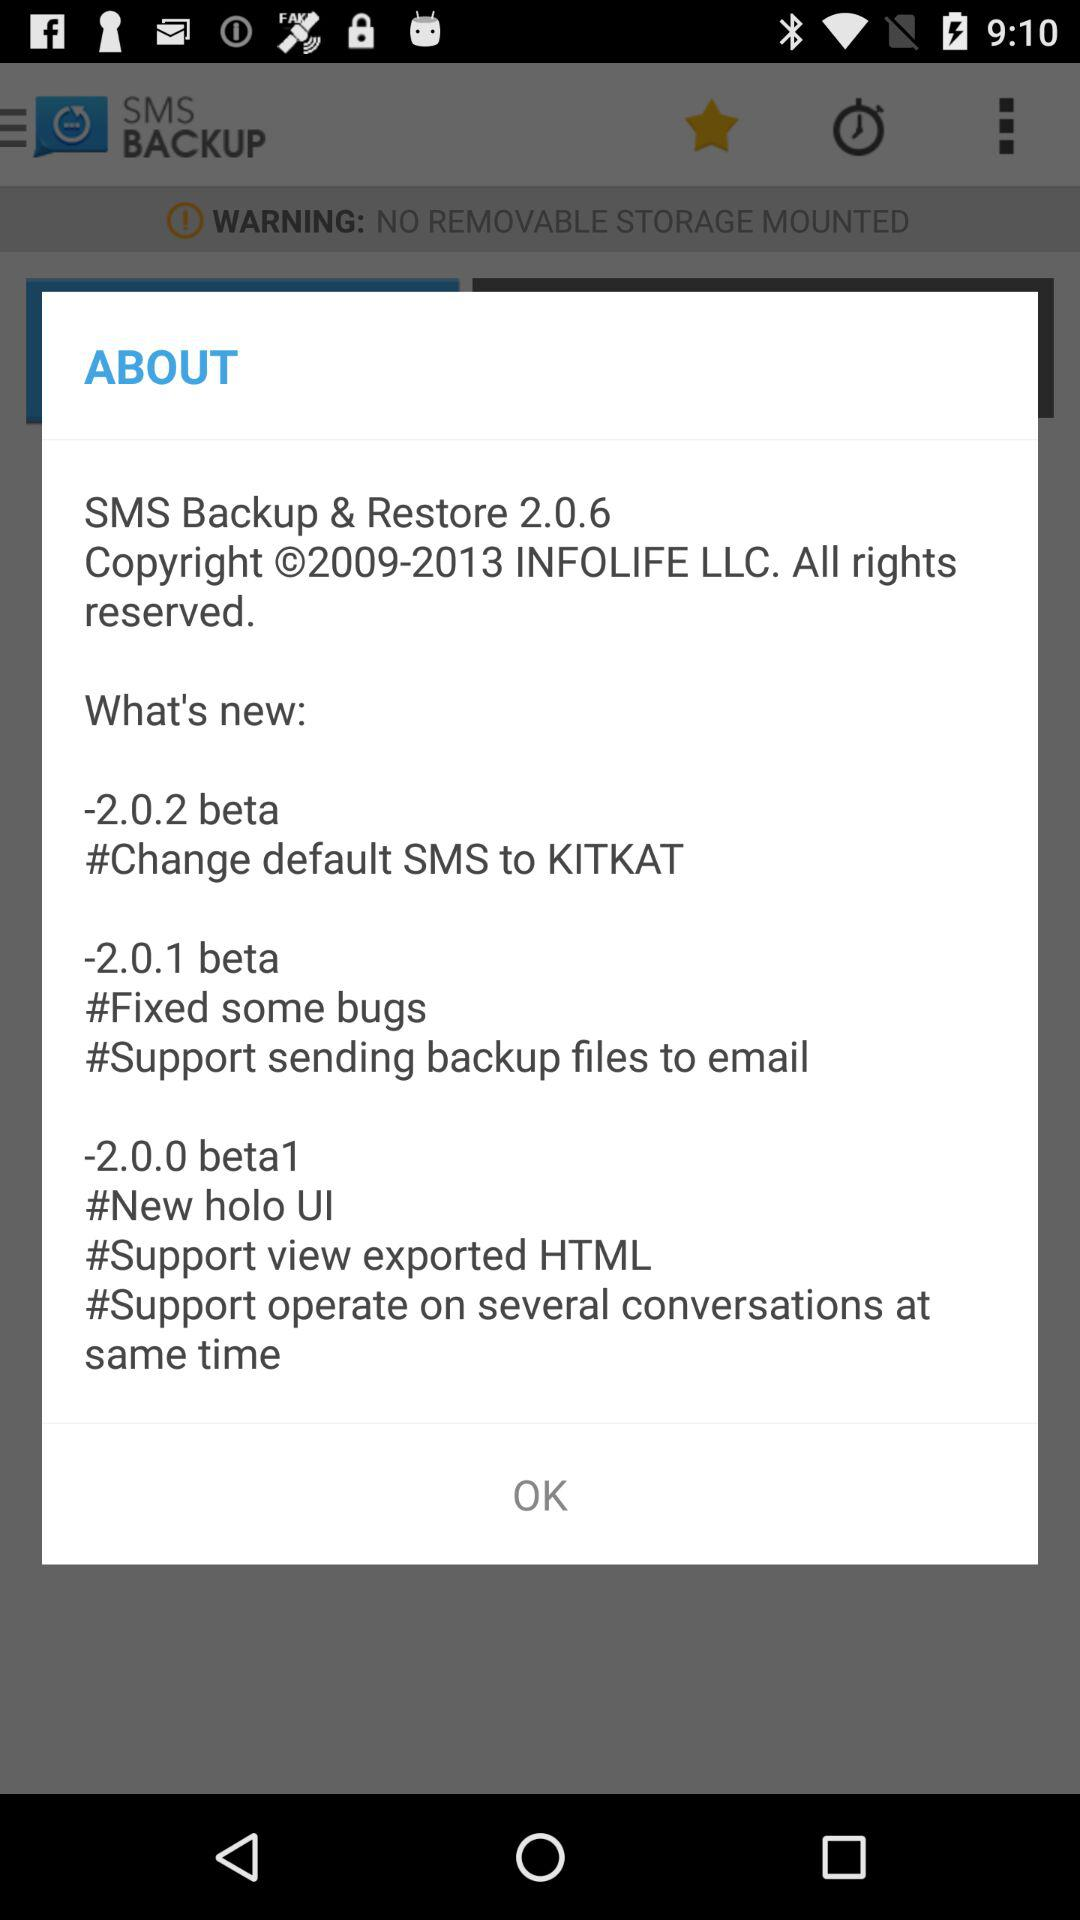Which are the different versions? The different versions are 2.0.6, 2.0.2 beta, 2.0.1 beta and 2.0.0 beta1. 